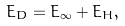<formula> <loc_0><loc_0><loc_500><loc_500>E _ { D } = E _ { \infty } + E _ { H } ,</formula> 